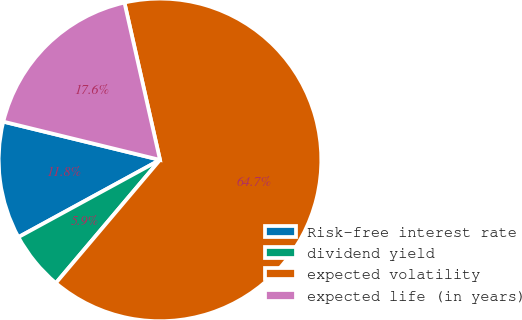Convert chart to OTSL. <chart><loc_0><loc_0><loc_500><loc_500><pie_chart><fcel>Risk-free interest rate<fcel>dividend yield<fcel>expected volatility<fcel>expected life (in years)<nl><fcel>11.76%<fcel>5.88%<fcel>64.71%<fcel>17.65%<nl></chart> 